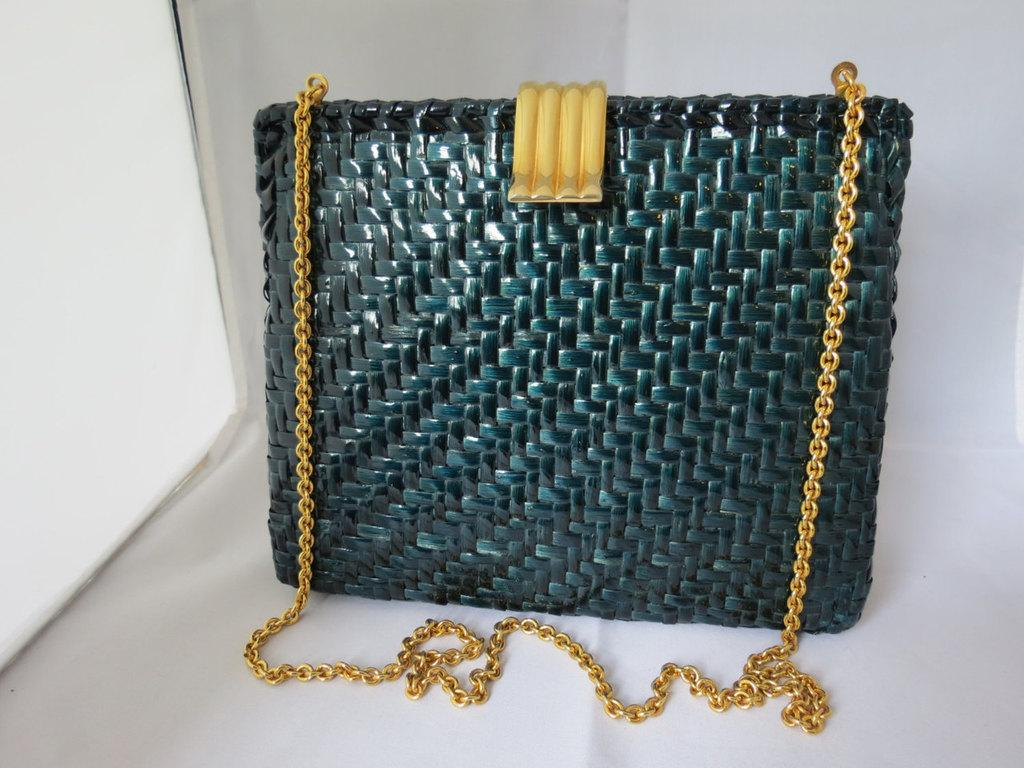What type of bag is visible in the image? The bag is a sling bag. What color is the sling bag? The bag is green in color. What additional feature can be seen on the sling bag? The bag has a golden chain. What type of soup is being served in the sling bag? There is no soup present in the image; it features a green sling bag with a golden chain. 